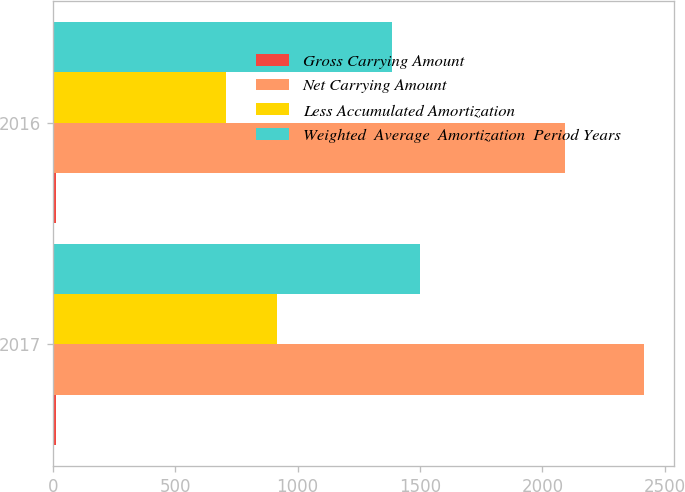<chart> <loc_0><loc_0><loc_500><loc_500><stacked_bar_chart><ecel><fcel>2017<fcel>2016<nl><fcel>Gross Carrying Amount<fcel>12<fcel>14<nl><fcel>Net Carrying Amount<fcel>2416<fcel>2091<nl><fcel>Less Accumulated Amortization<fcel>917<fcel>706<nl><fcel>Weighted  Average  Amortization  Period Years<fcel>1499<fcel>1385<nl></chart> 